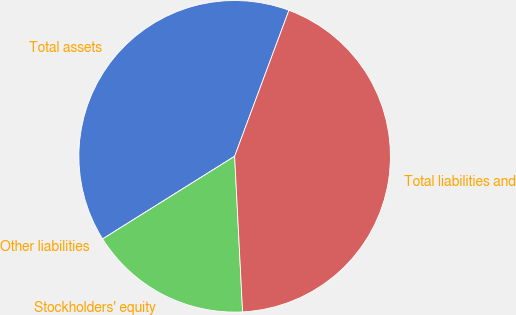Convert chart to OTSL. <chart><loc_0><loc_0><loc_500><loc_500><pie_chart><fcel>Total assets<fcel>Other liabilities<fcel>Stockholders' equity<fcel>Total liabilities and<nl><fcel>39.57%<fcel>0.0%<fcel>16.91%<fcel>43.52%<nl></chart> 